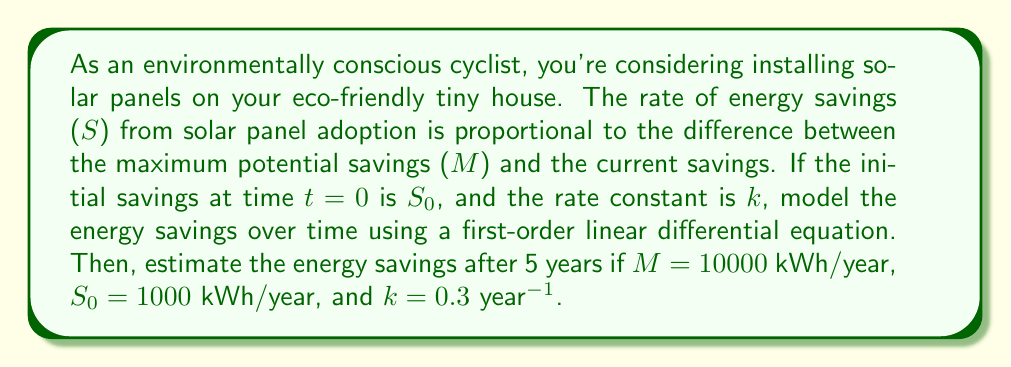Give your solution to this math problem. Let's approach this step-by-step:

1) The first-order linear differential equation describing this situation is:

   $$\frac{dS}{dt} = k(M - S)$$

   where $S$ is the energy savings, $t$ is time, $k$ is the rate constant, and $M$ is the maximum potential savings.

2) The general solution to this differential equation is:

   $$S(t) = M + (S_0 - M)e^{-kt}$$

3) We're given the following values:
   $M = 10000$ kWh/year
   $S_0 = 1000$ kWh/year
   $k = 0.3$ year$^{-1}$
   $t = 5$ years

4) Substituting these values into our solution:

   $$S(5) = 10000 + (1000 - 10000)e^{-0.3(5)}$$

5) Simplify:
   $$S(5) = 10000 - 9000e^{-1.5}$$

6) Calculate $e^{-1.5} \approx 0.2231$

7) Final calculation:
   $$S(5) = 10000 - 9000(0.2231) \approx 7992.1$$

Therefore, after 5 years, the estimated energy savings will be approximately 7992.1 kWh/year.

This model shows how the energy savings approach the maximum potential savings over time, which aligns with the gradual increase in efficiency and utilization of solar panels.
Answer: The estimated energy savings after 5 years is approximately 7992.1 kWh/year. 